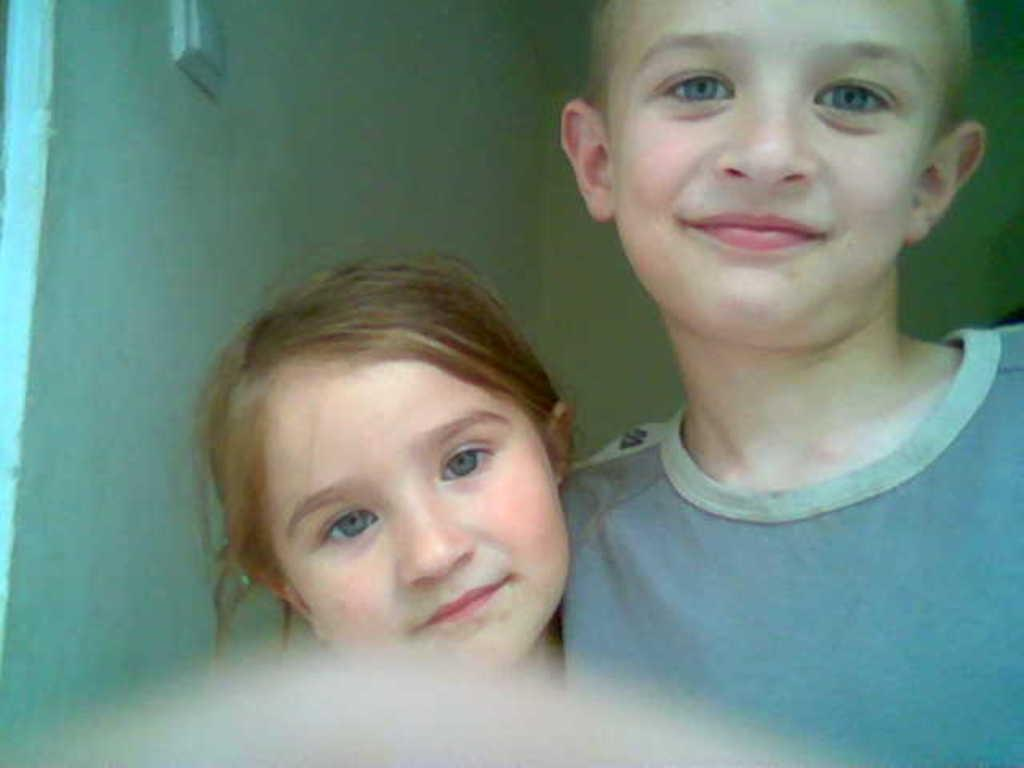How many individuals are present in the image? There are two people in the image. Can you describe the gender of the individuals? One of the people is a boy, and the other person is a girl. What is located behind the two people? There is a wall behind the two people. What type of tin can be seen in the hands of the girl in the image? There is no tin present in the image; the girl is not holding anything. 